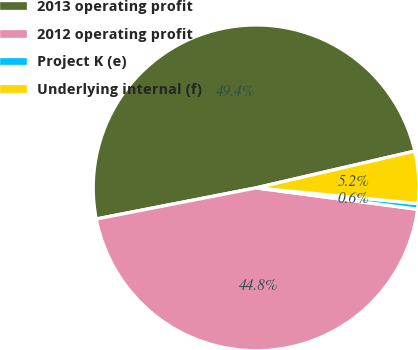Convert chart to OTSL. <chart><loc_0><loc_0><loc_500><loc_500><pie_chart><fcel>2013 operating profit<fcel>2012 operating profit<fcel>Project K (e)<fcel>Underlying internal (f)<nl><fcel>49.44%<fcel>44.84%<fcel>0.56%<fcel>5.16%<nl></chart> 